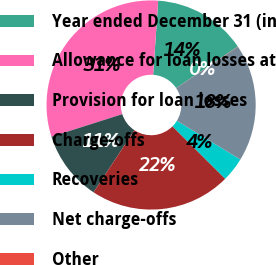Convert chart to OTSL. <chart><loc_0><loc_0><loc_500><loc_500><pie_chart><fcel>Year ended December 31 (in<fcel>Allowance for loan losses at<fcel>Provision for loan losses<fcel>Charge-offs<fcel>Recoveries<fcel>Net charge-offs<fcel>Other<nl><fcel>14.48%<fcel>30.99%<fcel>10.82%<fcel>21.81%<fcel>3.74%<fcel>18.14%<fcel>0.03%<nl></chart> 